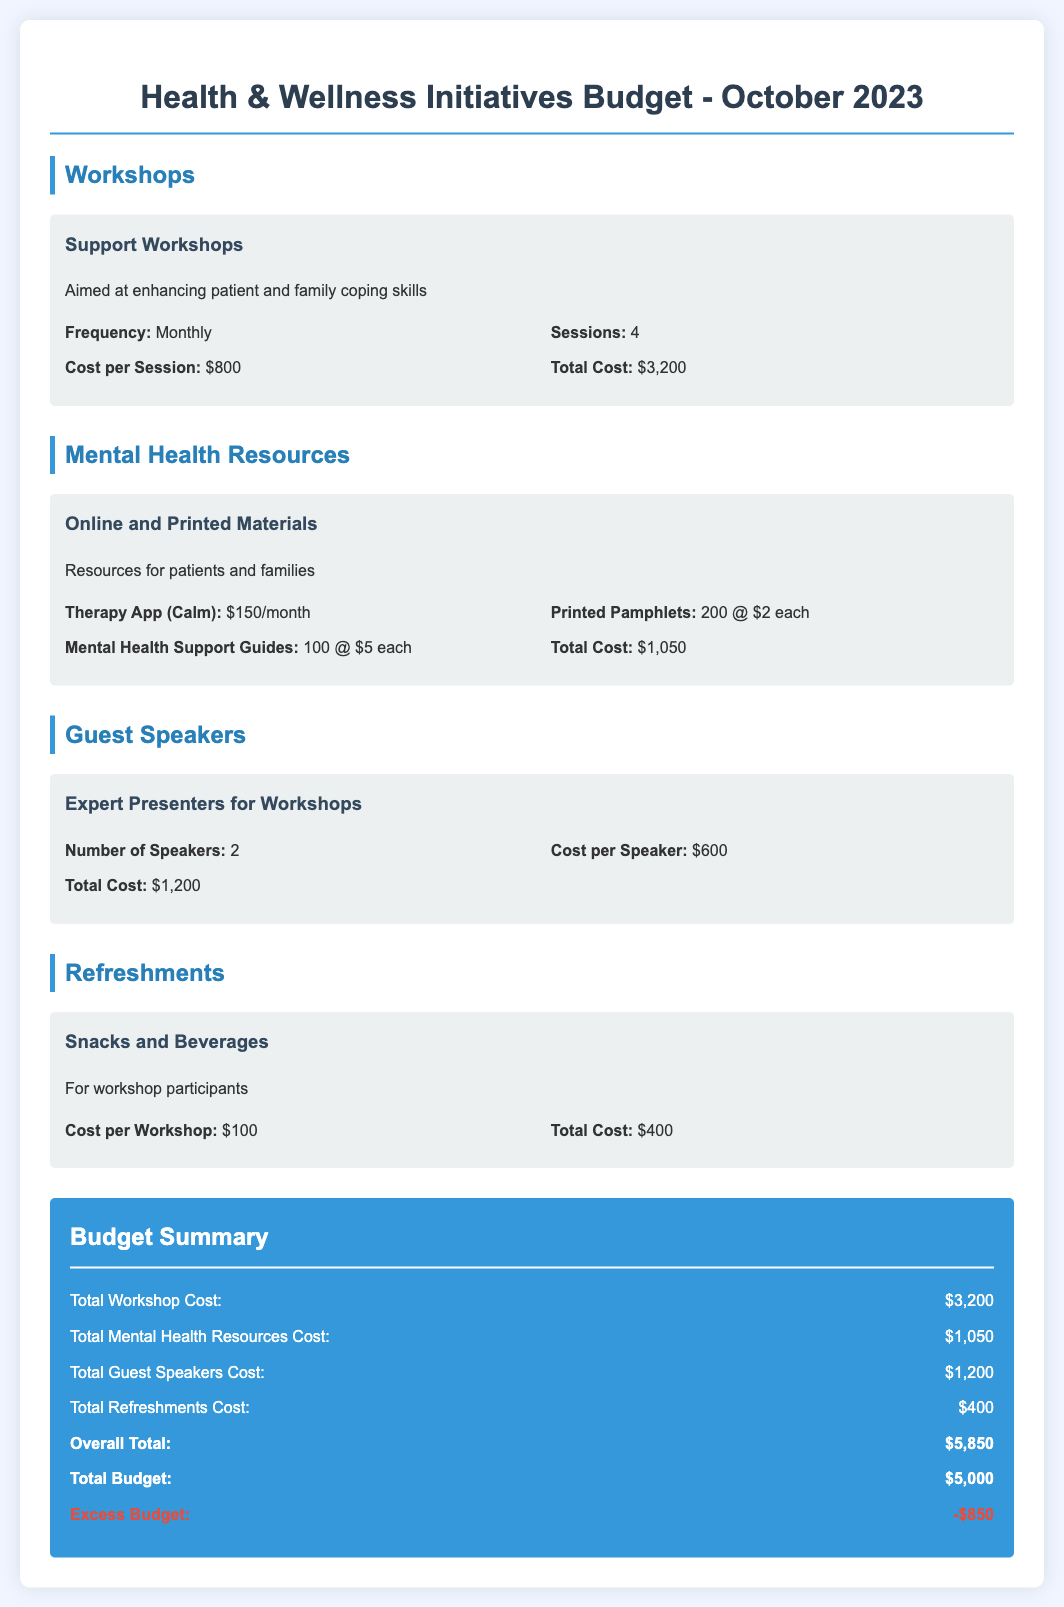What is the total cost for support workshops? The total cost for support workshops is indicated as $3,200.
Answer: $3,200 How many speakers are planned for the workshops? The document specifies that there are 2 speakers planned for the workshops.
Answer: 2 What is the cost of the therapy app per month? The document lists the therapy app cost as $150 per month.
Answer: $150 How many printed pamphlets are included in the budget? The budget mentions 200 printed pamphlets are included.
Answer: 200 What is the overall total budget allocation? The overall total budget allocation provided in the document is $5,850.
Answer: $5,850 What is the total cost for refreshments? The total cost for refreshments is stated as $400 in the budget.
Answer: $400 What is the excess budget amount? The excess budget amount shown in the document is -$850.
Answer: -$850 What is the cost per session for support workshops? The document specifies that the cost per session for support workshops is $800.
Answer: $800 What type of materials are allocated under mental health resources? The types of materials listed are online and printed materials for patients and families.
Answer: Online and Printed Materials 